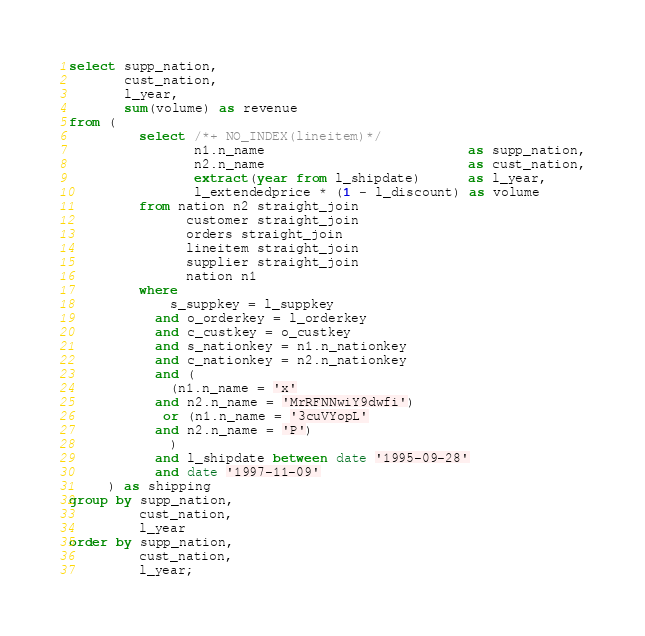<code> <loc_0><loc_0><loc_500><loc_500><_SQL_>select supp_nation,
       cust_nation,
       l_year,
       sum(volume) as revenue
from (
         select /*+ NO_INDEX(lineitem)*/
                n1.n_name                          as supp_nation,
                n2.n_name                          as cust_nation,
                extract(year from l_shipdate)      as l_year,
                l_extendedprice * (1 - l_discount) as volume
         from nation n2 straight_join
               customer straight_join
               orders straight_join
               lineitem straight_join
               supplier straight_join
               nation n1
         where
             s_suppkey = l_suppkey
           and o_orderkey = l_orderkey
           and c_custkey = o_custkey
           and s_nationkey = n1.n_nationkey
           and c_nationkey = n2.n_nationkey
           and (
             (n1.n_name = 'x'
           and n2.n_name = 'MrRFNNwiY9dwfi')
            or (n1.n_name = '3cuVYopL'
           and n2.n_name = 'P')
             )
           and l_shipdate between date '1995-09-28'
           and date '1997-11-09'
     ) as shipping
group by supp_nation,
         cust_nation,
         l_year
order by supp_nation,
         cust_nation,
         l_year;
</code> 